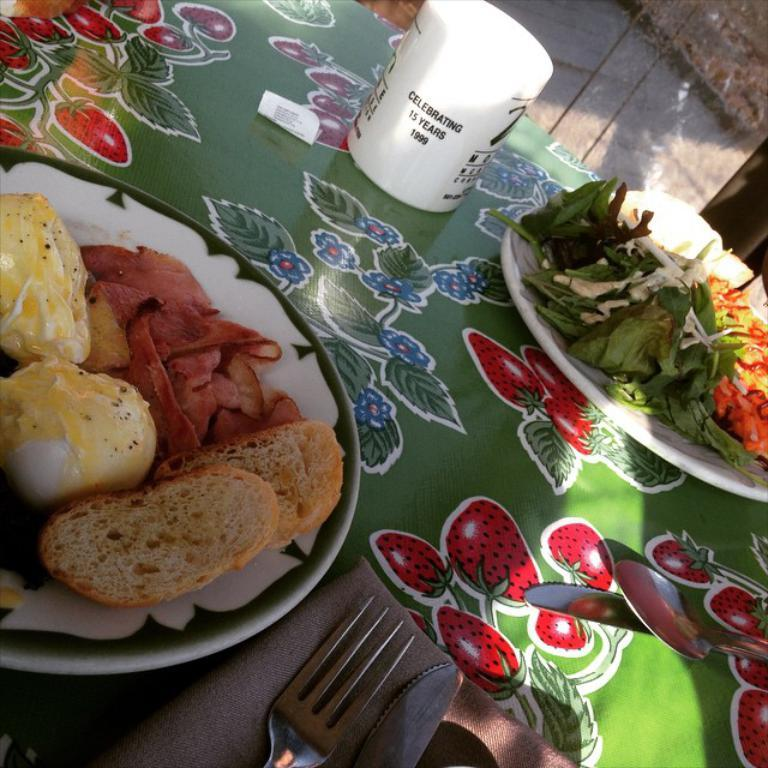What is located in the center of the image? There is a table in the center of the image. What can be seen on the table? There are two plates of food on the table. What utensil and item are located at the bottom of the image? There is a fork and a tissue at the bottom of the image. What is located at the top of the image? There is a cup at the top of the image. What type of pen can be seen on the table in the image? There is no pen present on the table in the image. What type of linen is draped over the table in the image? There is no linen present in the image; the table is not covered. 